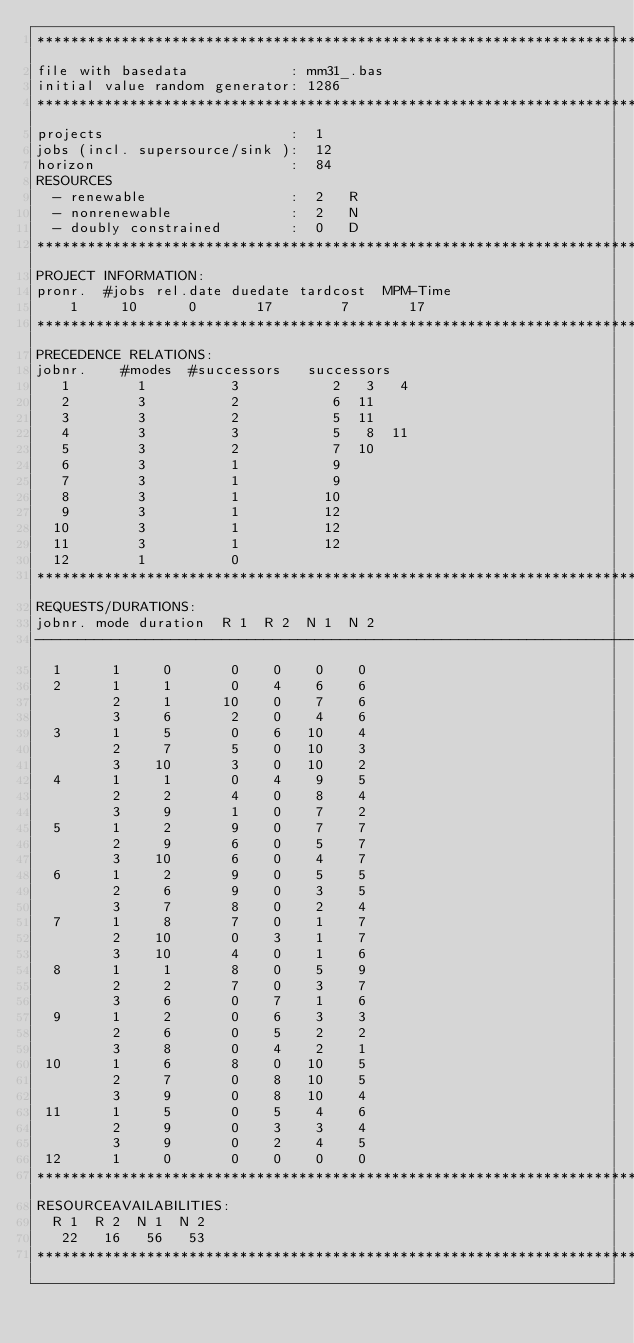<code> <loc_0><loc_0><loc_500><loc_500><_ObjectiveC_>************************************************************************
file with basedata            : mm31_.bas
initial value random generator: 1286
************************************************************************
projects                      :  1
jobs (incl. supersource/sink ):  12
horizon                       :  84
RESOURCES
  - renewable                 :  2   R
  - nonrenewable              :  2   N
  - doubly constrained        :  0   D
************************************************************************
PROJECT INFORMATION:
pronr.  #jobs rel.date duedate tardcost  MPM-Time
    1     10      0       17        7       17
************************************************************************
PRECEDENCE RELATIONS:
jobnr.    #modes  #successors   successors
   1        1          3           2   3   4
   2        3          2           6  11
   3        3          2           5  11
   4        3          3           5   8  11
   5        3          2           7  10
   6        3          1           9
   7        3          1           9
   8        3          1          10
   9        3          1          12
  10        3          1          12
  11        3          1          12
  12        1          0        
************************************************************************
REQUESTS/DURATIONS:
jobnr. mode duration  R 1  R 2  N 1  N 2
------------------------------------------------------------------------
  1      1     0       0    0    0    0
  2      1     1       0    4    6    6
         2     1      10    0    7    6
         3     6       2    0    4    6
  3      1     5       0    6   10    4
         2     7       5    0   10    3
         3    10       3    0   10    2
  4      1     1       0    4    9    5
         2     2       4    0    8    4
         3     9       1    0    7    2
  5      1     2       9    0    7    7
         2     9       6    0    5    7
         3    10       6    0    4    7
  6      1     2       9    0    5    5
         2     6       9    0    3    5
         3     7       8    0    2    4
  7      1     8       7    0    1    7
         2    10       0    3    1    7
         3    10       4    0    1    6
  8      1     1       8    0    5    9
         2     2       7    0    3    7
         3     6       0    7    1    6
  9      1     2       0    6    3    3
         2     6       0    5    2    2
         3     8       0    4    2    1
 10      1     6       8    0   10    5
         2     7       0    8   10    5
         3     9       0    8   10    4
 11      1     5       0    5    4    6
         2     9       0    3    3    4
         3     9       0    2    4    5
 12      1     0       0    0    0    0
************************************************************************
RESOURCEAVAILABILITIES:
  R 1  R 2  N 1  N 2
   22   16   56   53
************************************************************************
</code> 